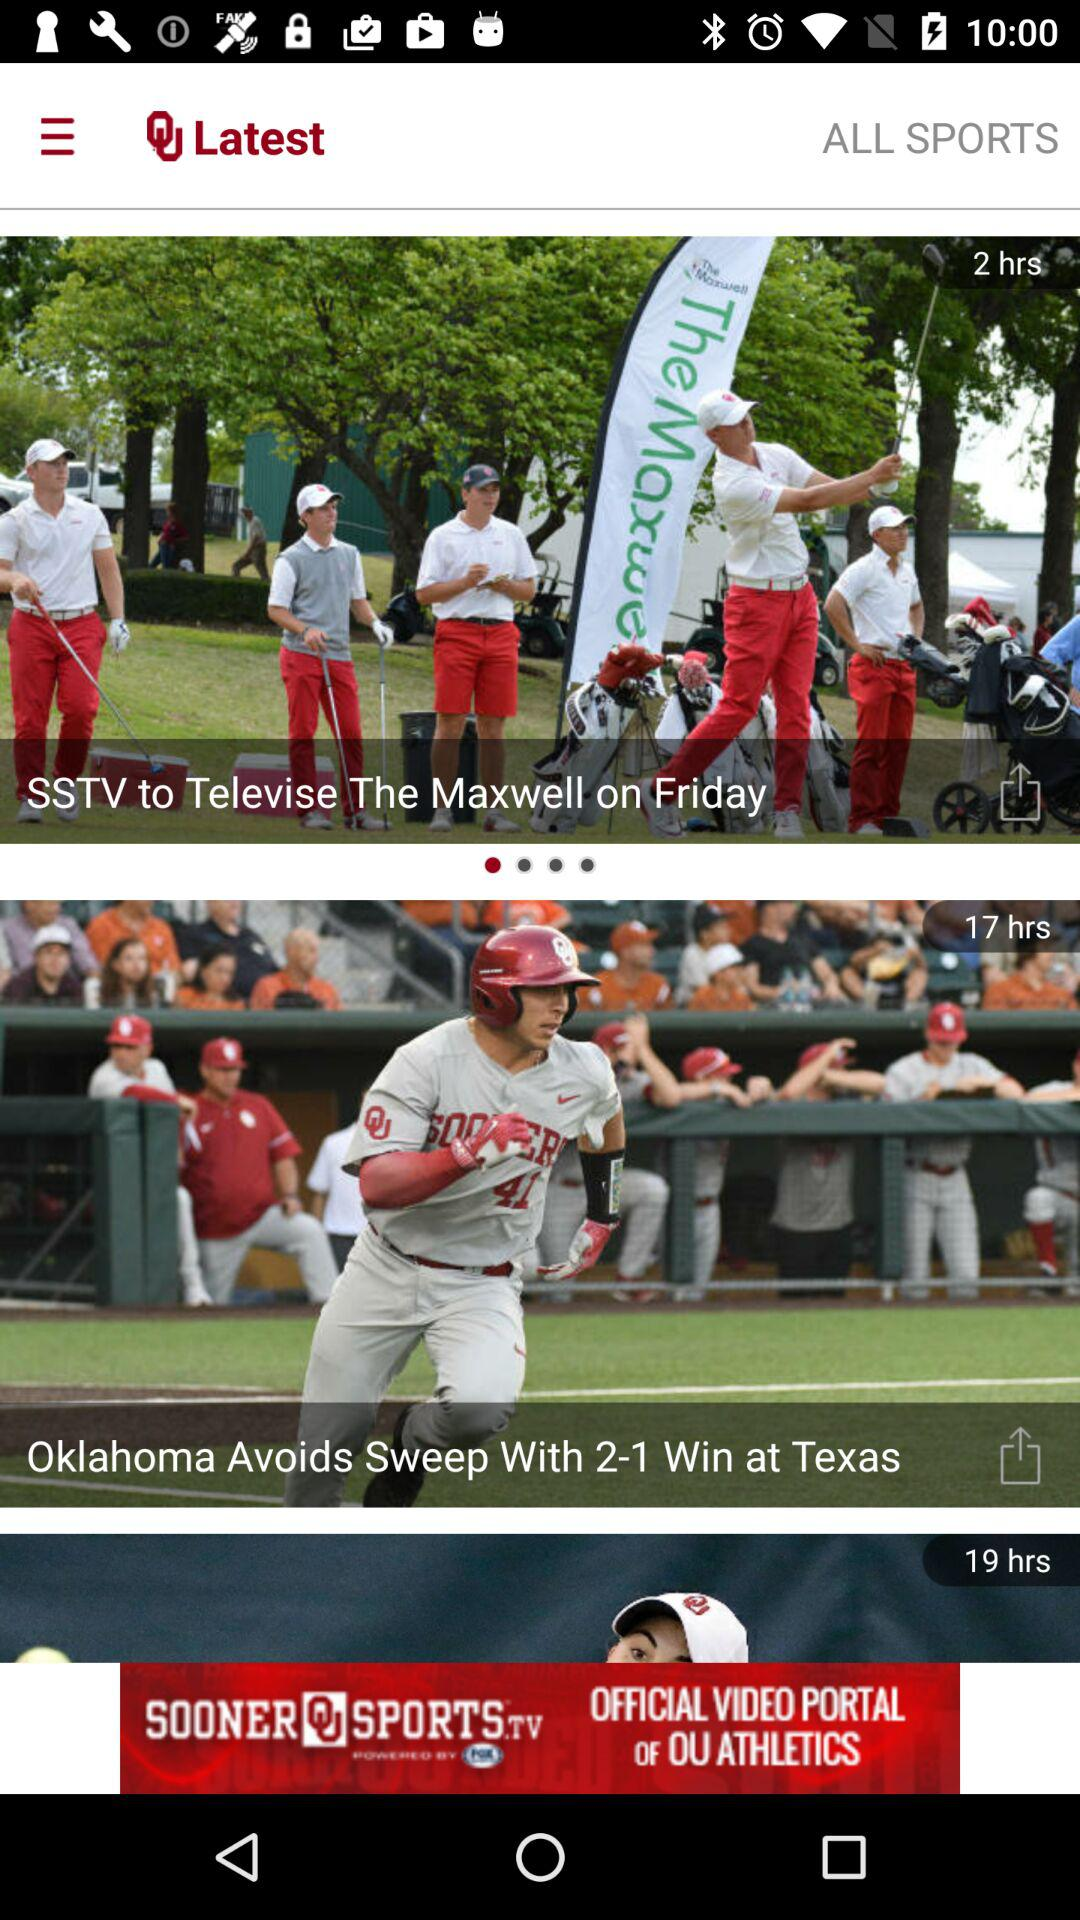What is the headline of the news that was posted 17 hours ago? The headline of the news that was posted 17 hours ago is "Oklahoma Avoids Sweep With 2-1 Win at Texas". 